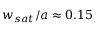<formula> <loc_0><loc_0><loc_500><loc_500>w _ { s a t } / a \approx 0 . 1 5</formula> 